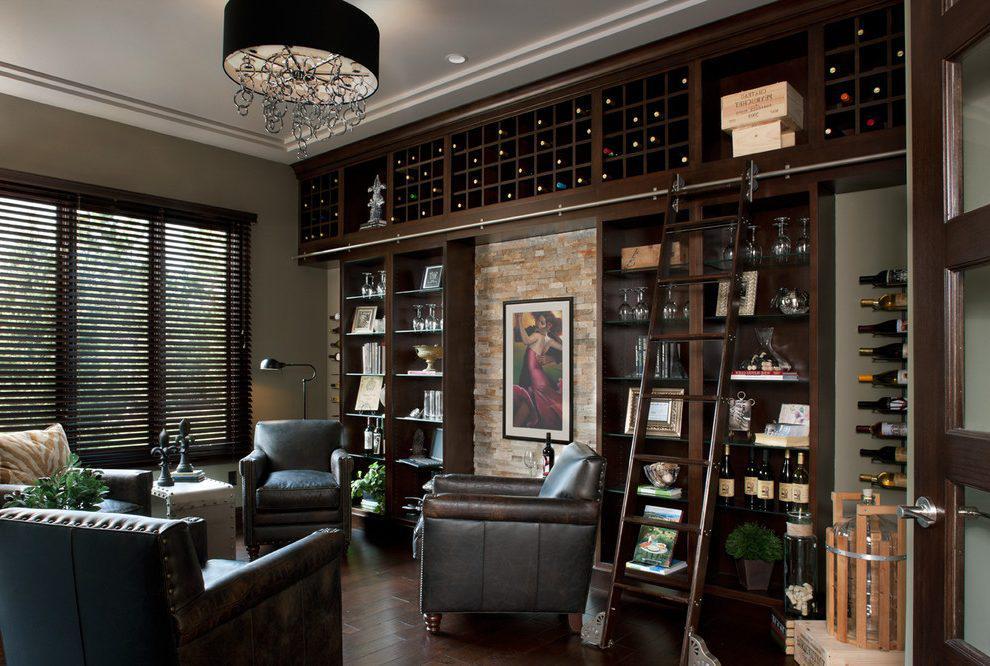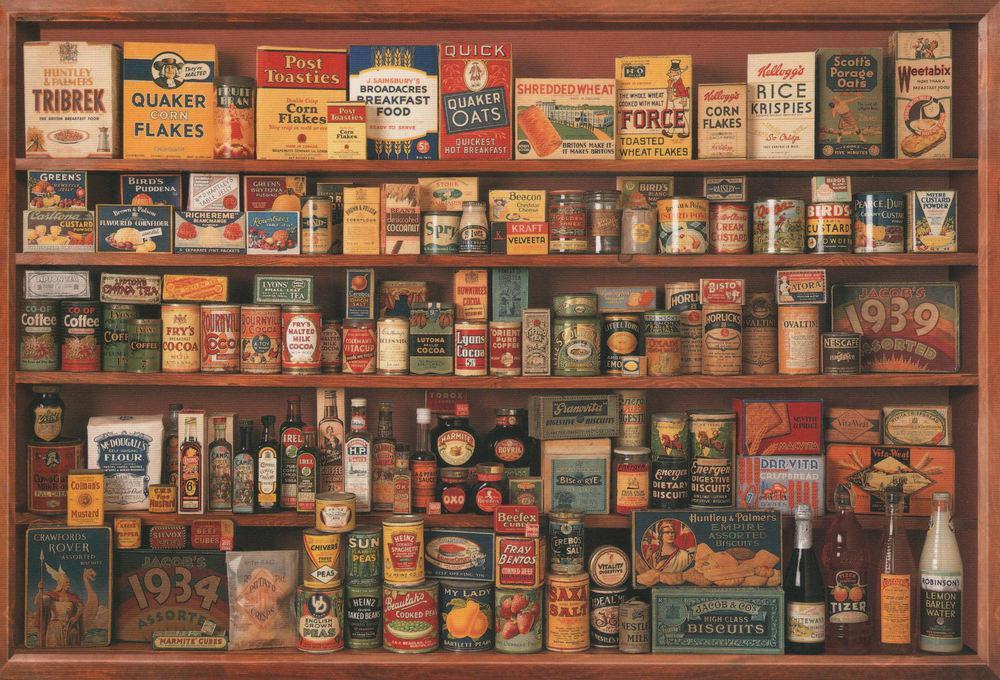The first image is the image on the left, the second image is the image on the right. For the images displayed, is the sentence "In one image there are books on a bookshelf locked up behind glass." factually correct? Answer yes or no. No. The first image is the image on the left, the second image is the image on the right. For the images shown, is this caption "there is a room with a bookshelf made of dark wood and a leather sofa in front of it" true? Answer yes or no. Yes. 